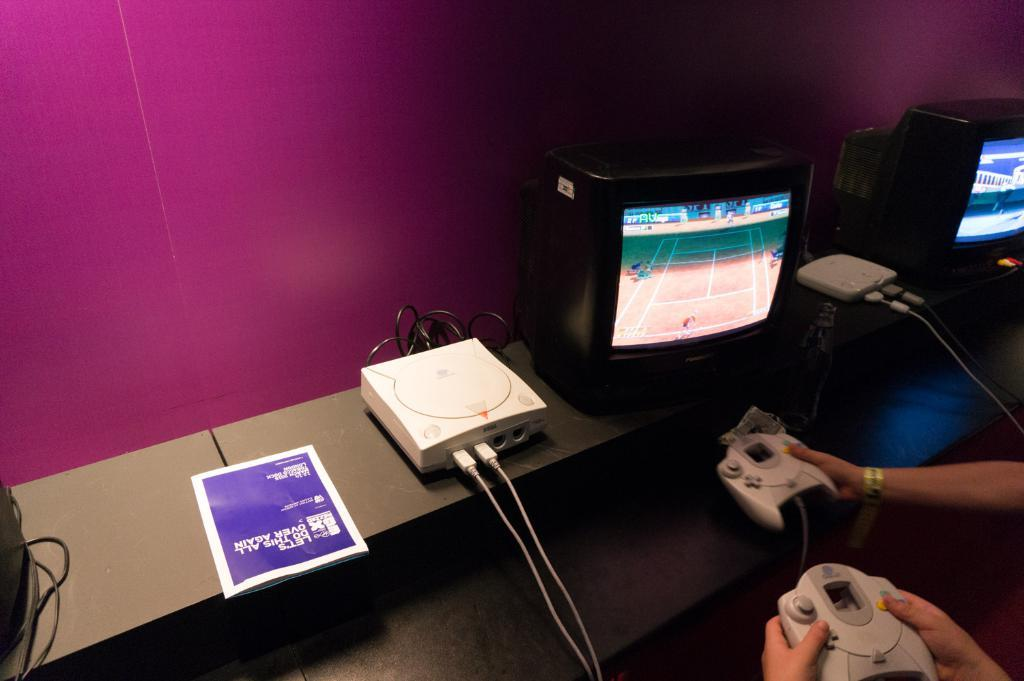<image>
Summarize the visual content of the image. A magazine called "Let's Do This All Over Again" sits on a TV shelf while two people play a video game. 